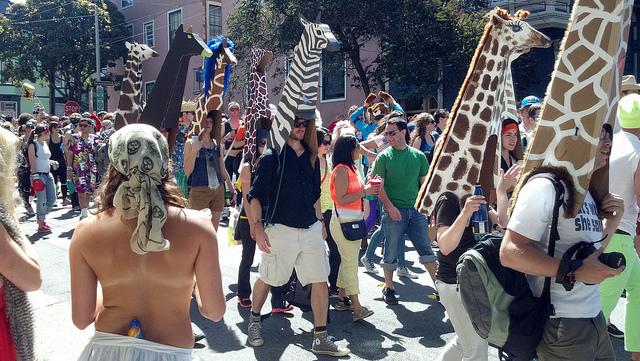Is one of the women topless?
Write a very short answer. Yes. What are they doing?
Write a very short answer. Parading. How many living things are shown?
Give a very brief answer. 50. Are the giraffes real?
Write a very short answer. No. Was this picture old?
Give a very brief answer. No. 